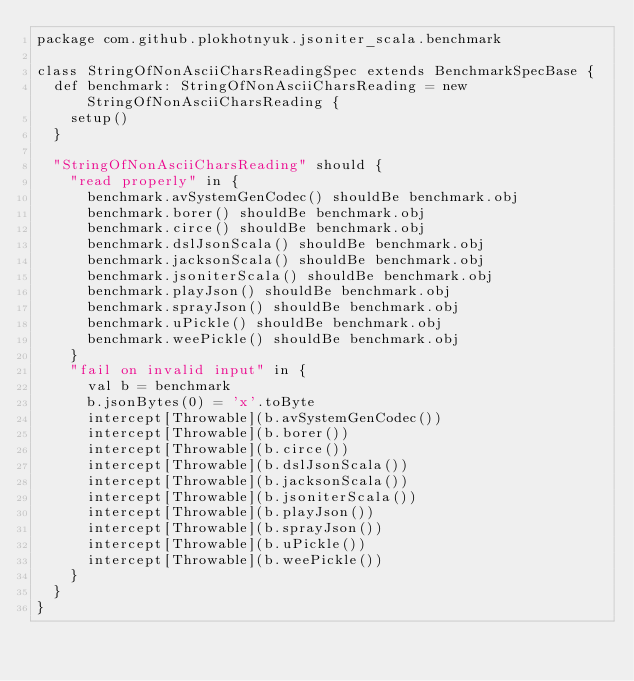Convert code to text. <code><loc_0><loc_0><loc_500><loc_500><_Scala_>package com.github.plokhotnyuk.jsoniter_scala.benchmark

class StringOfNonAsciiCharsReadingSpec extends BenchmarkSpecBase {
  def benchmark: StringOfNonAsciiCharsReading = new StringOfNonAsciiCharsReading {
    setup()
  }
  
  "StringOfNonAsciiCharsReading" should {
    "read properly" in {
      benchmark.avSystemGenCodec() shouldBe benchmark.obj
      benchmark.borer() shouldBe benchmark.obj
      benchmark.circe() shouldBe benchmark.obj
      benchmark.dslJsonScala() shouldBe benchmark.obj
      benchmark.jacksonScala() shouldBe benchmark.obj
      benchmark.jsoniterScala() shouldBe benchmark.obj
      benchmark.playJson() shouldBe benchmark.obj
      benchmark.sprayJson() shouldBe benchmark.obj
      benchmark.uPickle() shouldBe benchmark.obj
      benchmark.weePickle() shouldBe benchmark.obj
    }
    "fail on invalid input" in {
      val b = benchmark
      b.jsonBytes(0) = 'x'.toByte
      intercept[Throwable](b.avSystemGenCodec())
      intercept[Throwable](b.borer())
      intercept[Throwable](b.circe())
      intercept[Throwable](b.dslJsonScala())
      intercept[Throwable](b.jacksonScala())
      intercept[Throwable](b.jsoniterScala())
      intercept[Throwable](b.playJson())
      intercept[Throwable](b.sprayJson())
      intercept[Throwable](b.uPickle())
      intercept[Throwable](b.weePickle())
    }
  }
}</code> 